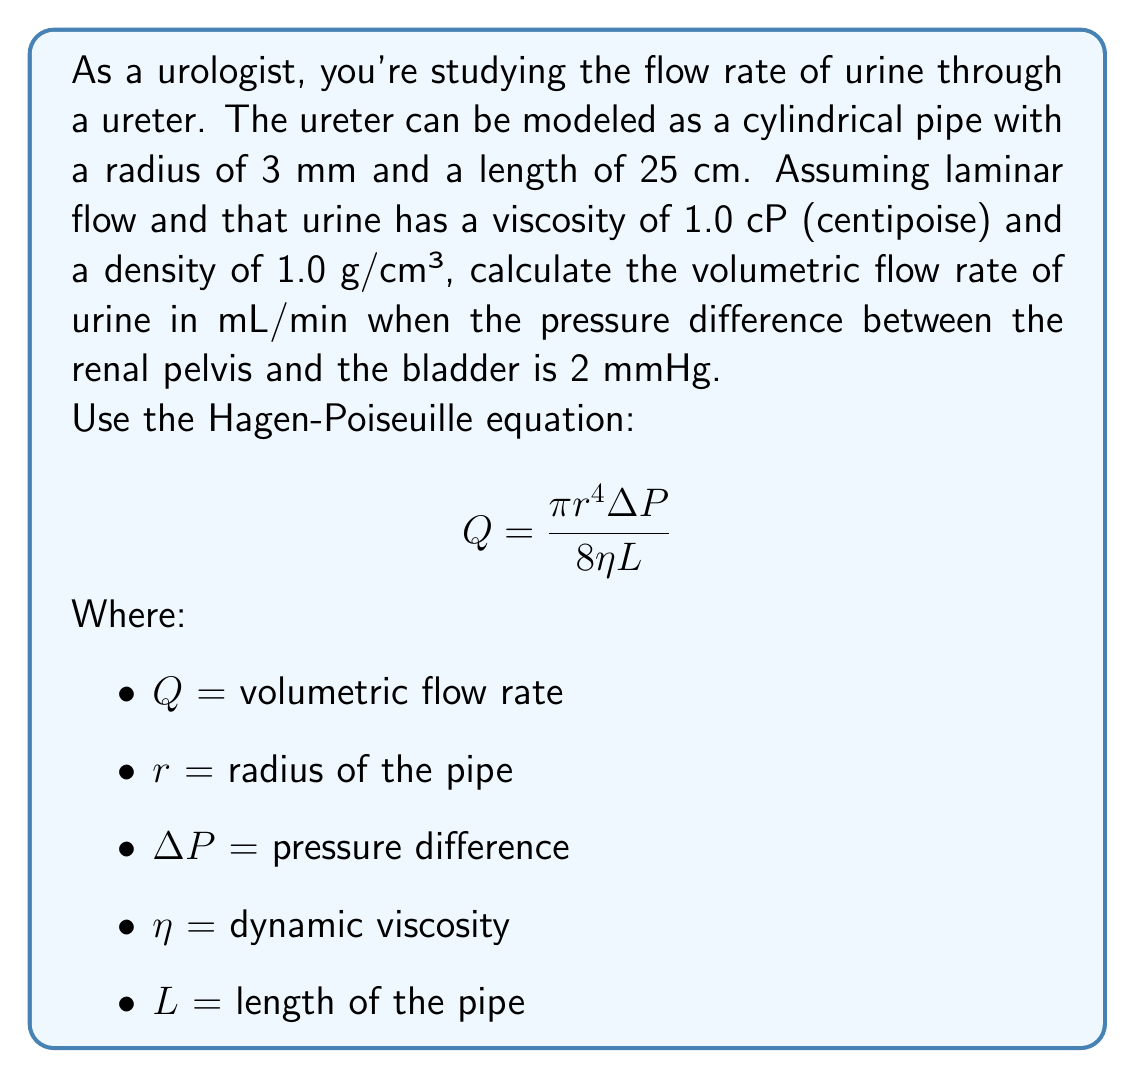What is the answer to this math problem? To solve this problem, we need to use the Hagen-Poiseuille equation and convert all units to a consistent system. Let's use CGS units (centimeters, grams, seconds).

Given:
- Radius ($r$) = 3 mm = 0.3 cm
- Length ($L$) = 25 cm
- Viscosity ($\eta$) = 1.0 cP = 0.01 g/(cm·s)
- Density = 1.0 g/cm³ (not needed for this calculation)
- Pressure difference ($\Delta P$) = 2 mmHg

Step 1: Convert pressure from mmHg to dynes/cm²
1 mmHg = 1333.22 dynes/cm²
$\Delta P = 2 \times 1333.22 = 2666.44$ dynes/cm²

Step 2: Apply the Hagen-Poiseuille equation
$$Q = \frac{\pi r^4 \Delta P}{8 \eta L}$$

$$Q = \frac{\pi (0.3)^4 (2666.44)}{8 (0.01) (25)}$$

Step 3: Calculate
$$Q = \frac{3.14159 \times 0.0081 \times 2666.44}{8 \times 0.01 \times 25}$$
$$Q = 0.8478 \text{ cm³/s}$$

Step 4: Convert to mL/min
$0.8478 \text{ cm³/s} \times 60 \text{ s/min} = 50.87 \text{ mL/min}$

Therefore, the volumetric flow rate of urine through the ureter under these conditions is approximately 50.87 mL/min.
Answer: 50.87 mL/min 